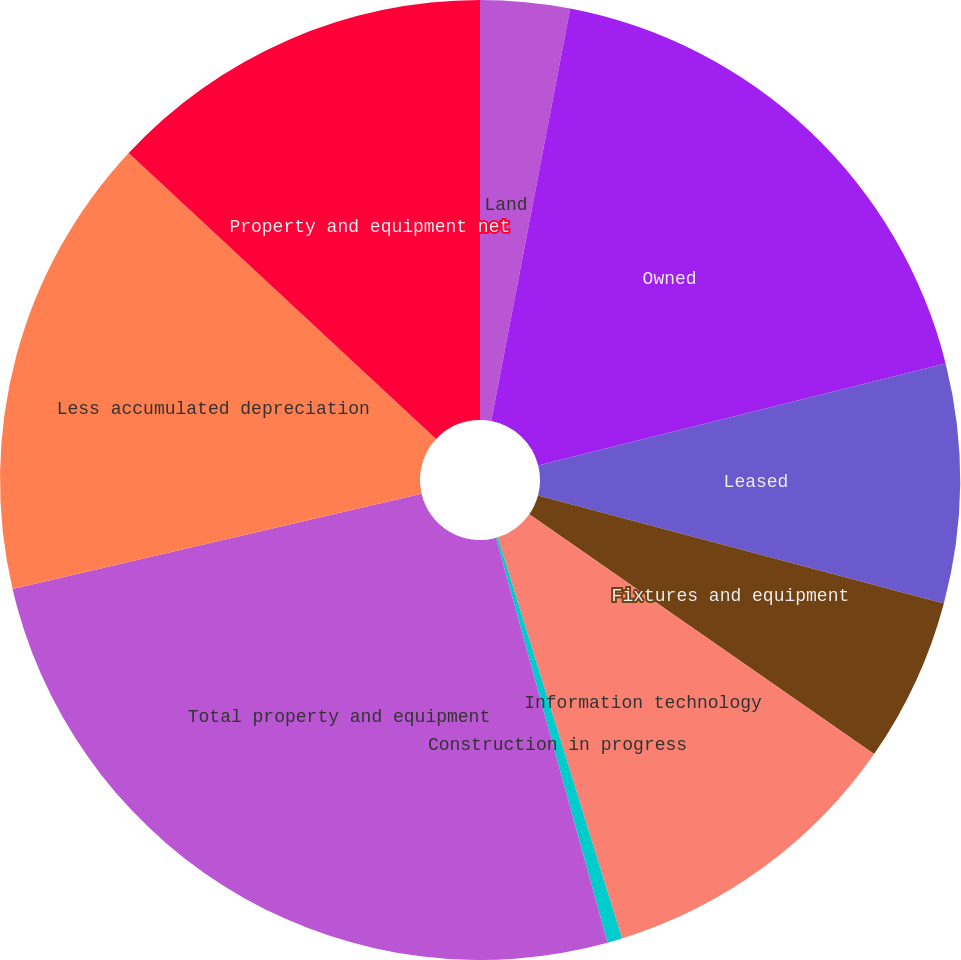Convert chart. <chart><loc_0><loc_0><loc_500><loc_500><pie_chart><fcel>Land<fcel>Owned<fcel>Leased<fcel>Fixtures and equipment<fcel>Information technology<fcel>Construction in progress<fcel>Total property and equipment<fcel>Less accumulated depreciation<fcel>Property and equipment net<nl><fcel>3.01%<fcel>18.09%<fcel>8.04%<fcel>5.53%<fcel>10.55%<fcel>0.5%<fcel>25.63%<fcel>15.58%<fcel>13.07%<nl></chart> 